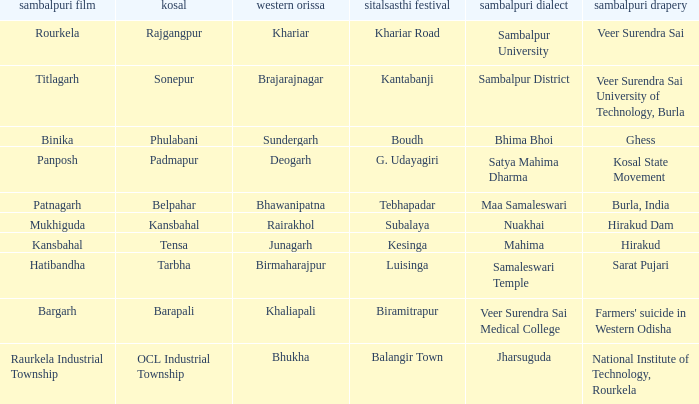What is the kosal with hatibandha as the sambalpuri cinema? Tarbha. 